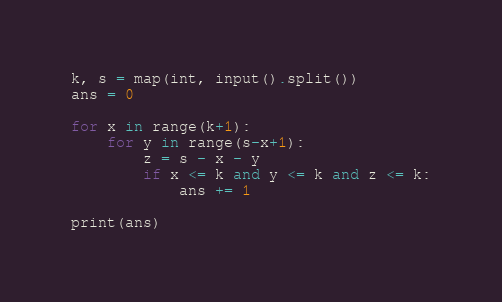Convert code to text. <code><loc_0><loc_0><loc_500><loc_500><_Python_>
k, s = map(int, input().split())
ans = 0

for x in range(k+1):
    for y in range(s-x+1):
        z = s - x - y
        if x <= k and y <= k and z <= k:
            ans += 1

print(ans)
</code> 